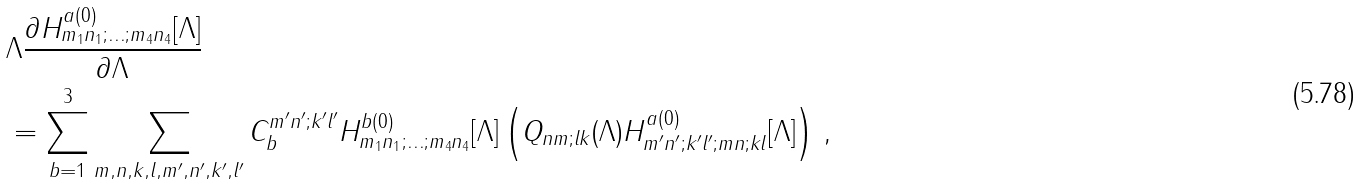<formula> <loc_0><loc_0><loc_500><loc_500>& \Lambda \frac { \partial H ^ { a ( 0 ) } _ { m _ { 1 } n _ { 1 } ; \dots ; m _ { 4 } n _ { 4 } } [ \Lambda ] } { \partial \Lambda } \\ & = \sum _ { b = 1 } ^ { 3 } \sum _ { m , n , k , l , m ^ { \prime } , n ^ { \prime } , k ^ { \prime } , l ^ { \prime } } C _ { b } ^ { m ^ { \prime } n ^ { \prime } ; k ^ { \prime } l ^ { \prime } } H ^ { b ( 0 ) } _ { m _ { 1 } n _ { 1 } ; \dots ; m _ { 4 } n _ { 4 } } [ \Lambda ] \left ( Q _ { n m ; l k } ( \Lambda ) H ^ { a ( 0 ) } _ { m ^ { \prime } n ^ { \prime } ; k ^ { \prime } l ^ { \prime } ; m n ; k l } [ \Lambda ] \right ) \, ,</formula> 